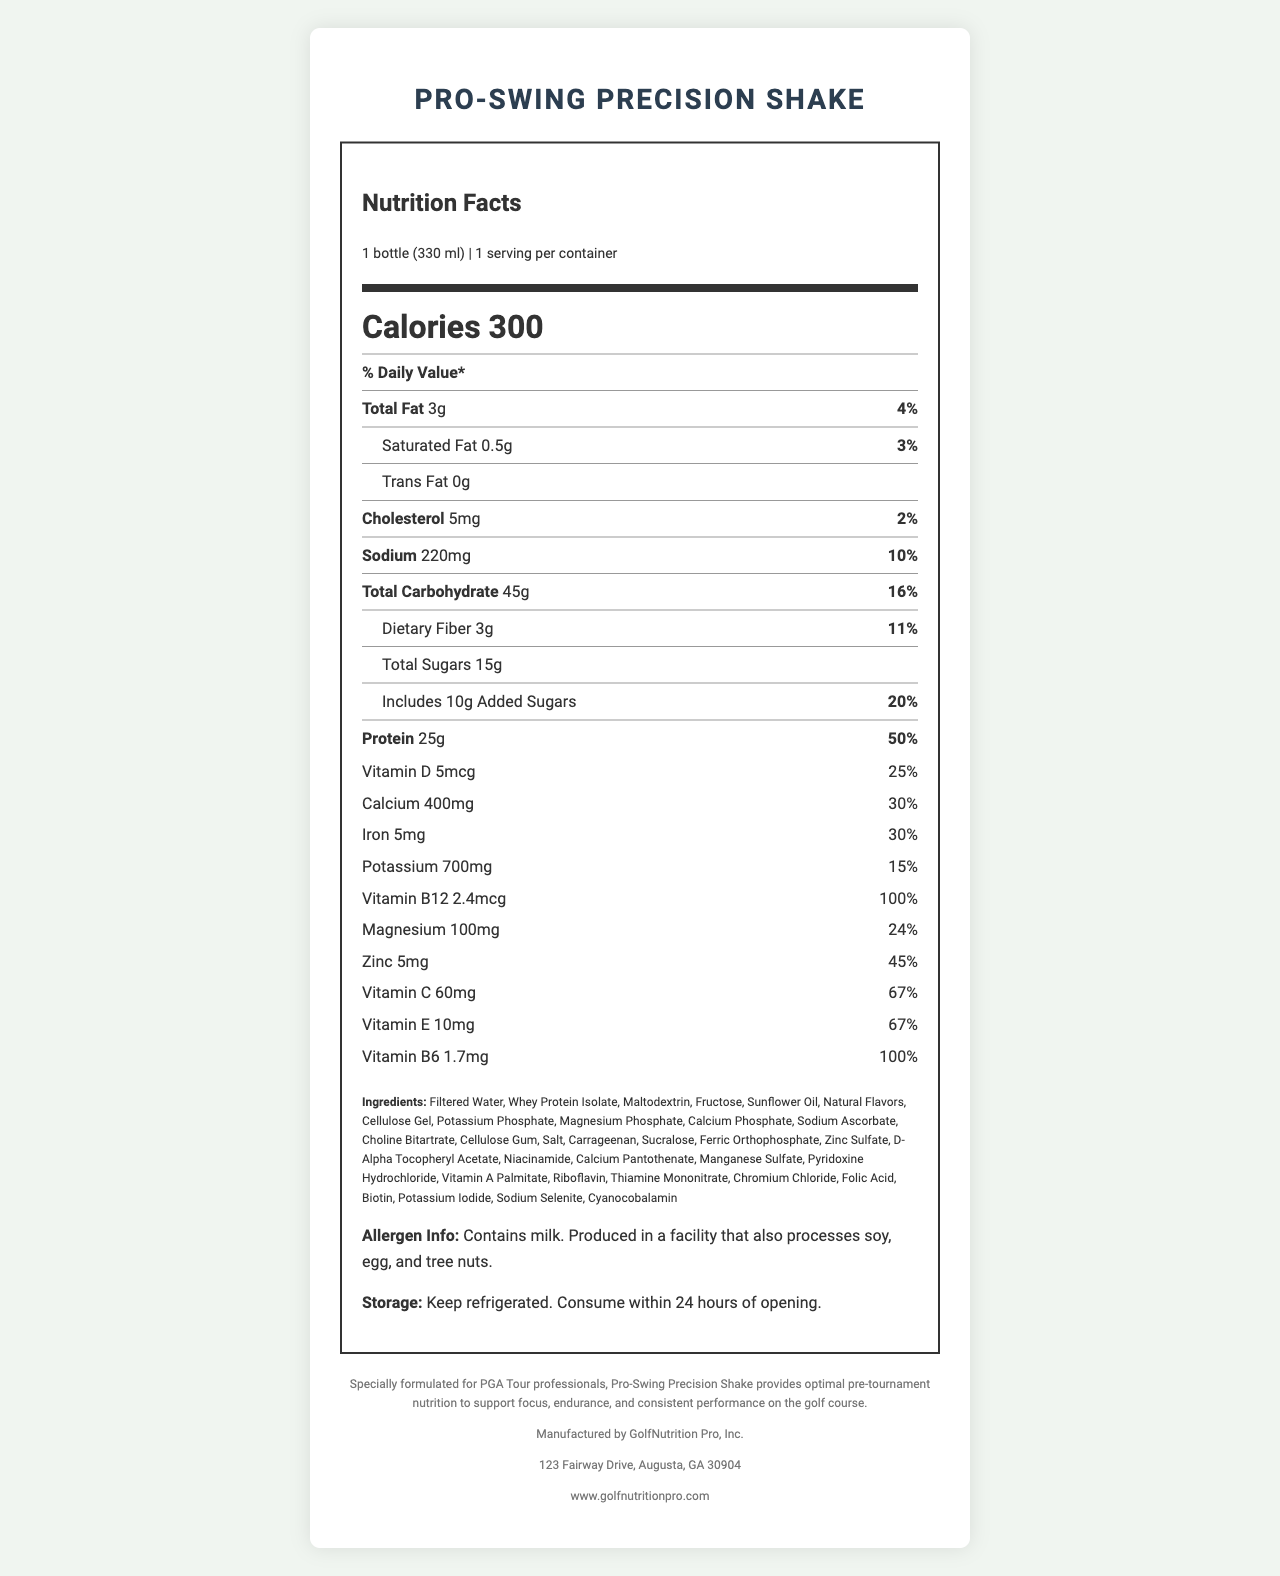what is the serving size of the Pro-Swing Precision Shake? The serving size is specified as "1 bottle (330 ml)" on the Nutrition Facts label.
Answer: 1 bottle (330 ml) how many calories are in one serving of the shake? The Nutrition Facts label lists the number of calories per serving as 300.
Answer: 300 what percentage of the daily value of dietary fiber does the shake provide? The label specifies that the shake contains 3g of dietary fiber, which equals 11% of the daily value.
Answer: 11% how much protein is in one bottle of the shake? The label indicates that there are 25g of protein per serving.
Answer: 25g what is the amount of Vitamin B12 in the shake? According to the label, the shake contains 2.4mcg of Vitamin B12.
Answer: 2.4mcg How much total sugar does the shake contain? The label specifies that there are 15g of total sugars in the shake.
Answer: 15g what is the address of the manufacturer? A. 123 Fairway Drive, Augusta, CA 30904 B. 321 Golf Road, Atlanta, GA 30904 C. 123 Fairway Drive, Augusta, GA 30904 D. 321 Golf Road, Atlanta, CA 30904 The label lists the manufacturer's address as "123 Fairway Drive, Augusta, GA 30904."
Answer: C which of the following vitamins are present in the shake? I. Vitamin C II. Vitamin E III. Vitamin K IV. Vitamin B6 The label lists Vitamin C, Vitamin E, and Vitamin B6 as present in the shake, but not Vitamin K.
Answer: I, II, IV Does the shake contain any trans fats? The label specifies "Trans Fat 0g," indicating there are no trans fats in the shake.
Answer: No Is this product produced in a facility that processes tree nuts? The allergen information on the label states that the product is produced in a facility that also processes soy, egg, and tree nuts.
Answer: Yes Summarize the main idea of the document. The document introduces the Pro-Swing Precision Shake, highlighting its nutritional benefits tailored for pre-tournament nutrition, its key ingredients, allergen information, and storage instructions.
Answer: The Pro-Swing Precision Shake is a vitamin-fortified meal replacement created for PGA Tour professionals to support focus, endurance, and performance. It contains 300 calories, 25g of protein, various vitamins and minerals, and must be refrigerated and consumed within 24 hours of opening. What is the primary flavor of the Pro-Swing Precision Shake? The label does not provide any information about the primary flavor of the shake.
Answer: Not enough information 